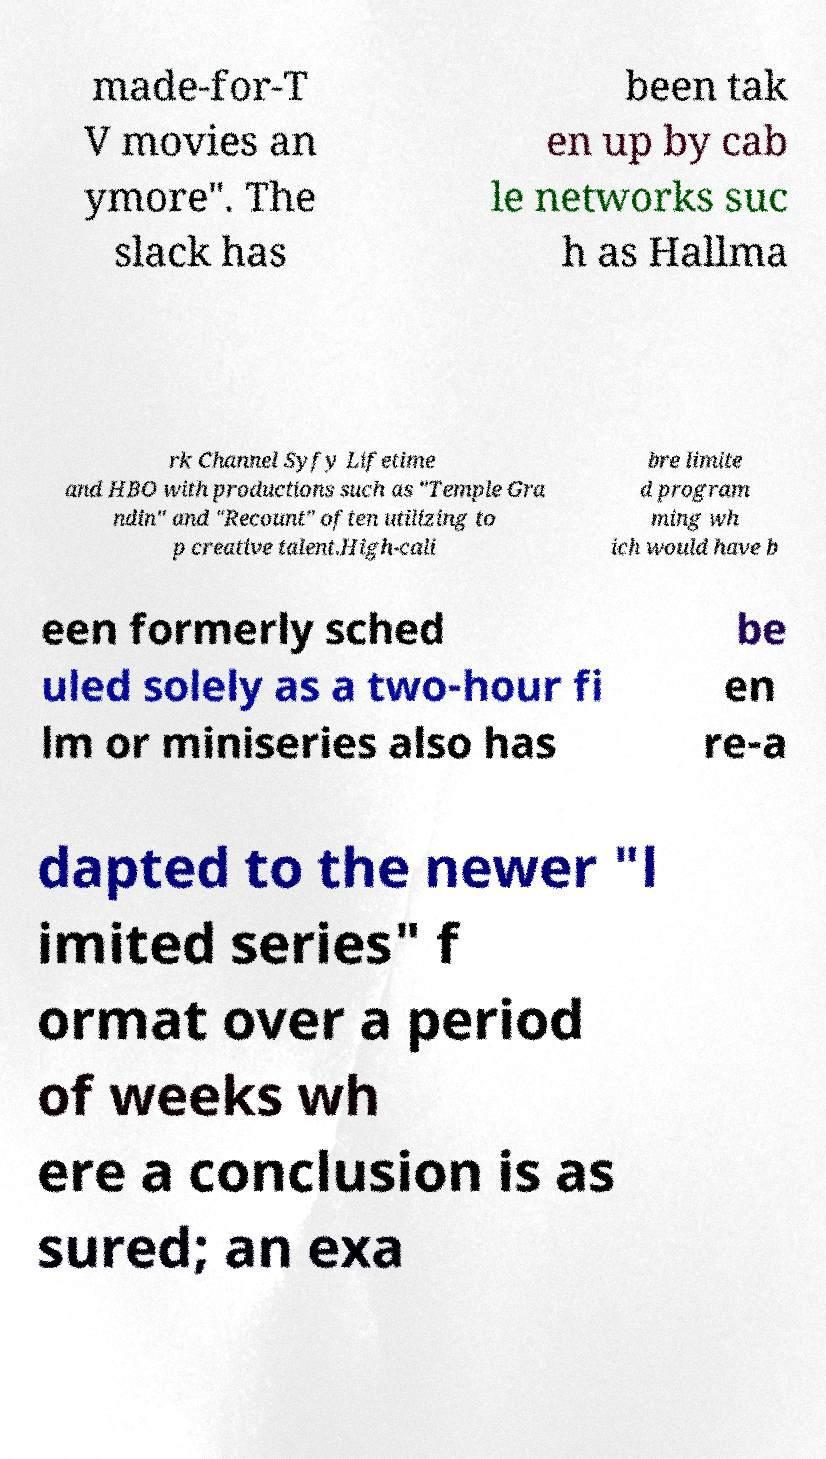Can you read and provide the text displayed in the image?This photo seems to have some interesting text. Can you extract and type it out for me? made-for-T V movies an ymore". The slack has been tak en up by cab le networks suc h as Hallma rk Channel Syfy Lifetime and HBO with productions such as "Temple Gra ndin" and "Recount" often utilizing to p creative talent.High-cali bre limite d program ming wh ich would have b een formerly sched uled solely as a two-hour fi lm or miniseries also has be en re-a dapted to the newer "l imited series" f ormat over a period of weeks wh ere a conclusion is as sured; an exa 